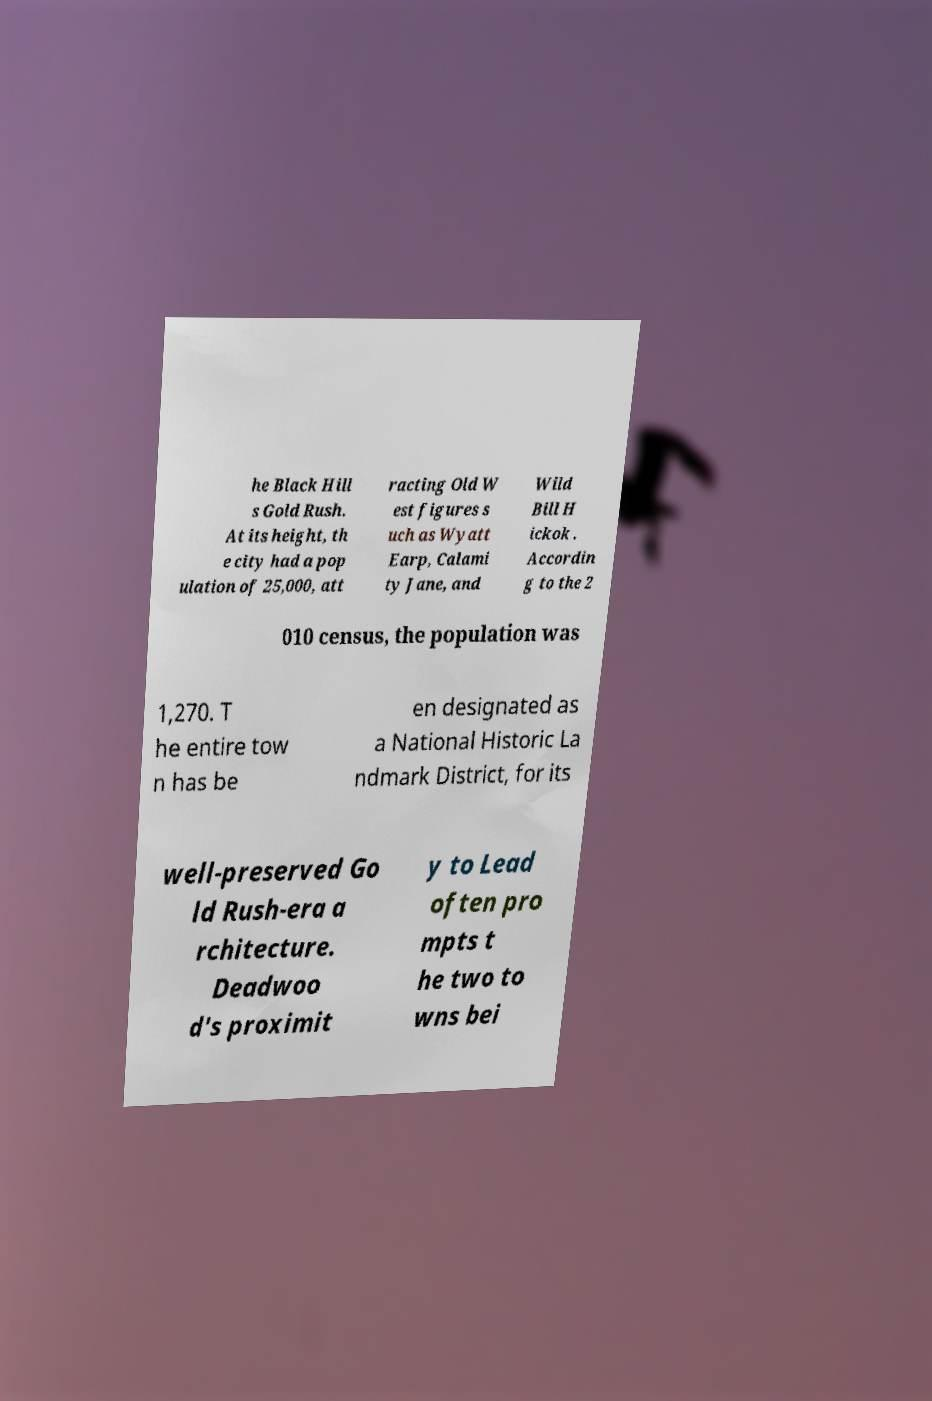There's text embedded in this image that I need extracted. Can you transcribe it verbatim? he Black Hill s Gold Rush. At its height, th e city had a pop ulation of 25,000, att racting Old W est figures s uch as Wyatt Earp, Calami ty Jane, and Wild Bill H ickok . Accordin g to the 2 010 census, the population was 1,270. T he entire tow n has be en designated as a National Historic La ndmark District, for its well-preserved Go ld Rush-era a rchitecture. Deadwoo d's proximit y to Lead often pro mpts t he two to wns bei 